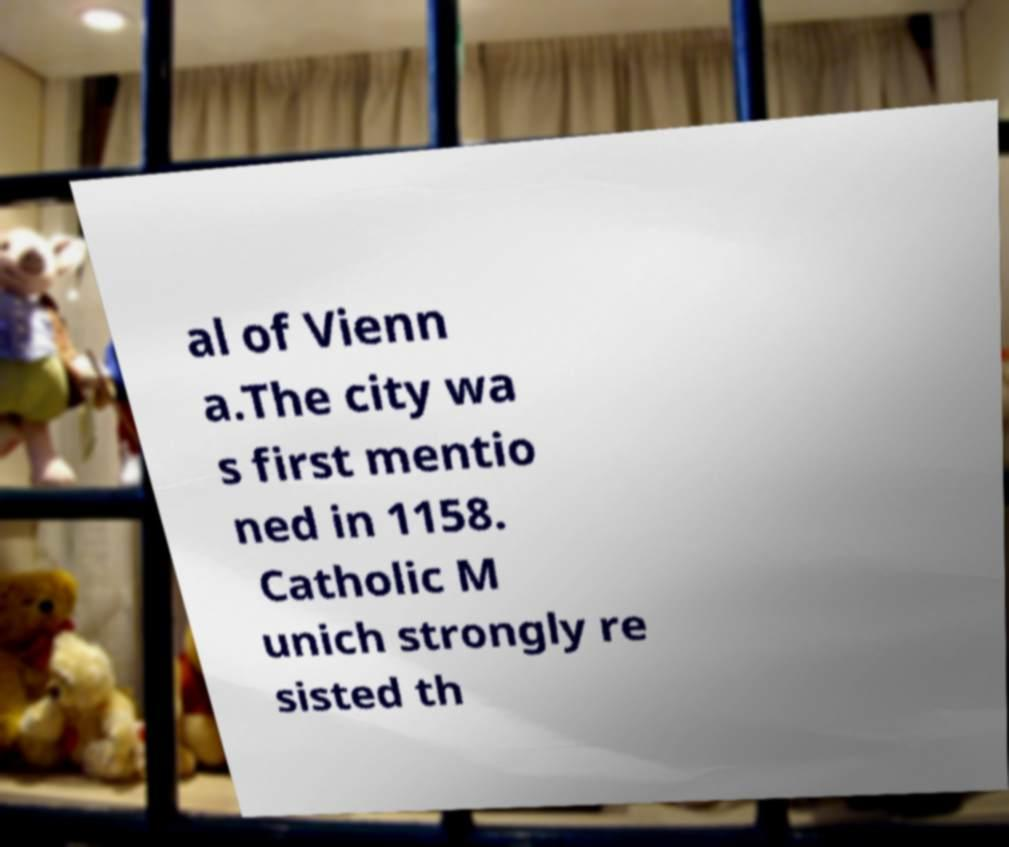There's text embedded in this image that I need extracted. Can you transcribe it verbatim? al of Vienn a.The city wa s first mentio ned in 1158. Catholic M unich strongly re sisted th 